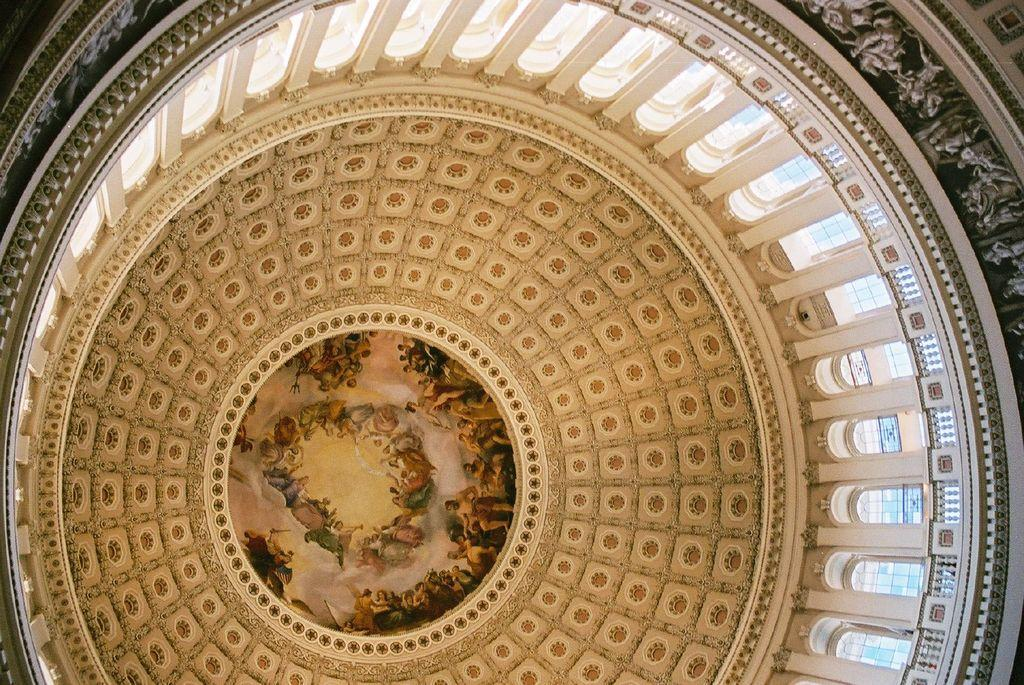What is the main subject of the image? The main subject of the image is a dome. What type of eggs can be seen in the image? There are no eggs present in the image; it features a dome. What is the smell like in the image? There is no information about the smell in the image, as it only shows a dome. Can you see a train in the image? There is no train present in the image; it features a dome. 